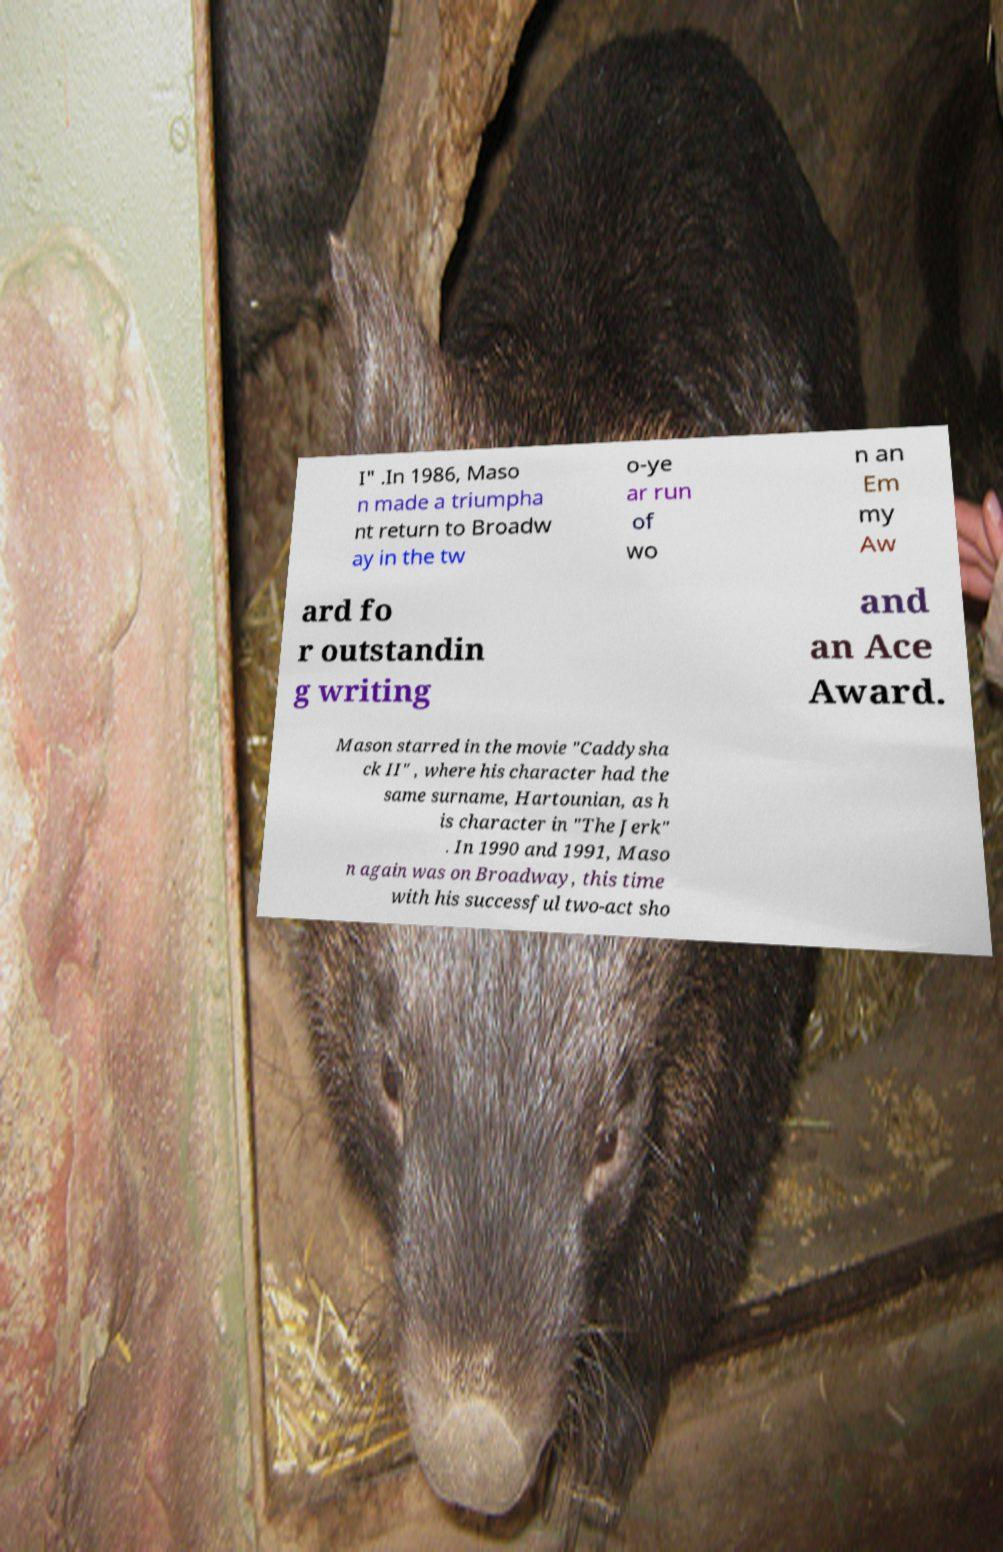Could you extract and type out the text from this image? I" .In 1986, Maso n made a triumpha nt return to Broadw ay in the tw o-ye ar run of wo n an Em my Aw ard fo r outstandin g writing and an Ace Award. Mason starred in the movie "Caddysha ck II" , where his character had the same surname, Hartounian, as h is character in "The Jerk" . In 1990 and 1991, Maso n again was on Broadway, this time with his successful two-act sho 